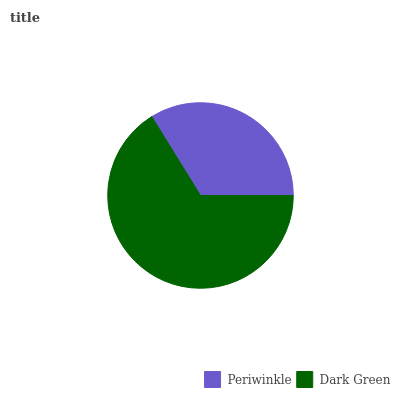Is Periwinkle the minimum?
Answer yes or no. Yes. Is Dark Green the maximum?
Answer yes or no. Yes. Is Dark Green the minimum?
Answer yes or no. No. Is Dark Green greater than Periwinkle?
Answer yes or no. Yes. Is Periwinkle less than Dark Green?
Answer yes or no. Yes. Is Periwinkle greater than Dark Green?
Answer yes or no. No. Is Dark Green less than Periwinkle?
Answer yes or no. No. Is Dark Green the high median?
Answer yes or no. Yes. Is Periwinkle the low median?
Answer yes or no. Yes. Is Periwinkle the high median?
Answer yes or no. No. Is Dark Green the low median?
Answer yes or no. No. 